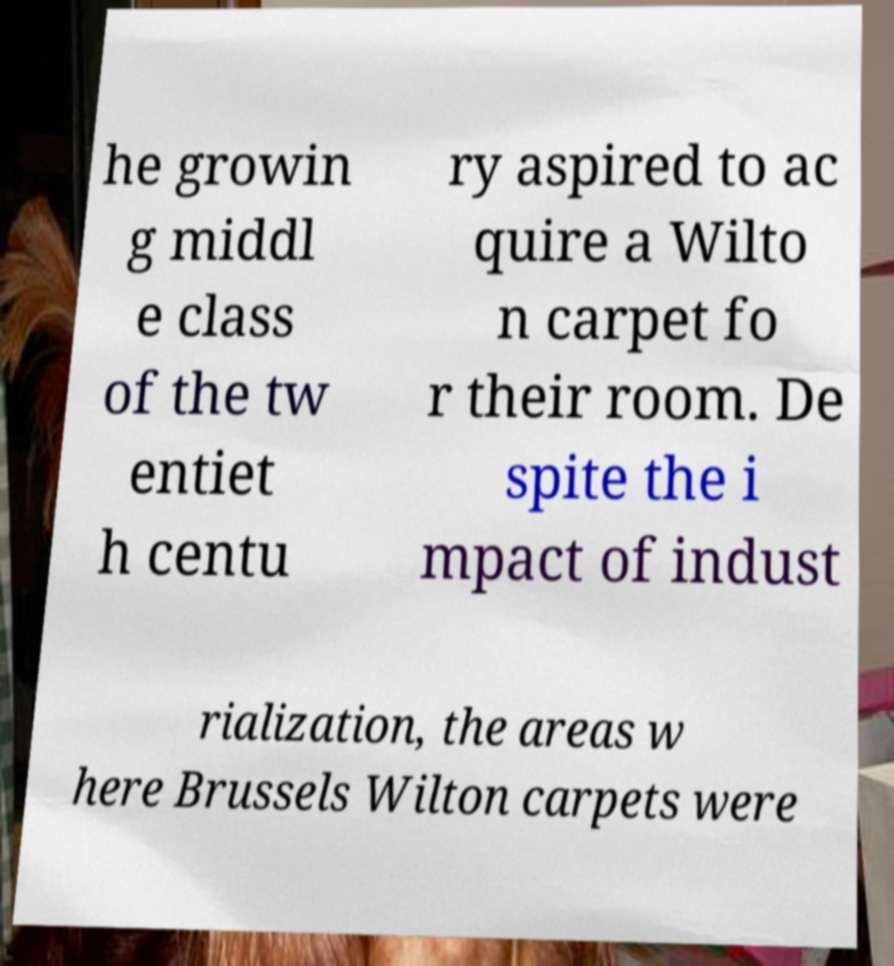Can you read and provide the text displayed in the image?This photo seems to have some interesting text. Can you extract and type it out for me? he growin g middl e class of the tw entiet h centu ry aspired to ac quire a Wilto n carpet fo r their room. De spite the i mpact of indust rialization, the areas w here Brussels Wilton carpets were 